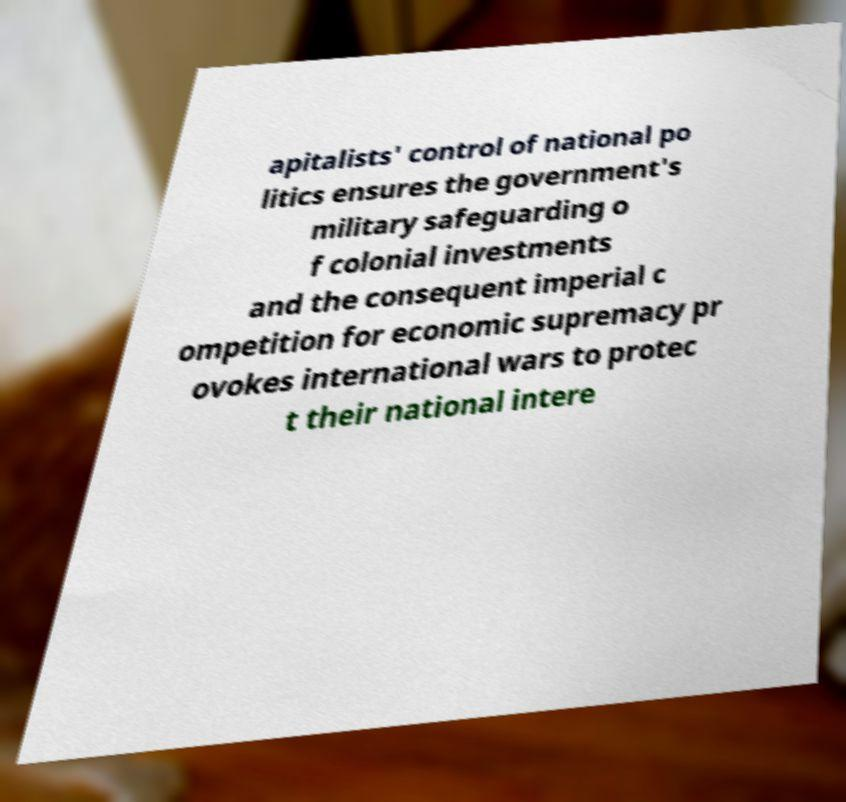What messages or text are displayed in this image? I need them in a readable, typed format. apitalists' control of national po litics ensures the government's military safeguarding o f colonial investments and the consequent imperial c ompetition for economic supremacy pr ovokes international wars to protec t their national intere 